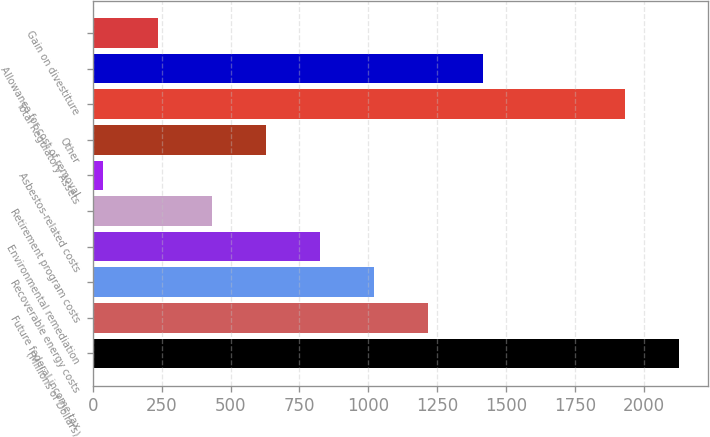<chart> <loc_0><loc_0><loc_500><loc_500><bar_chart><fcel>(Millions of Dollars)<fcel>Future federal income tax<fcel>Recoverable energy costs<fcel>Environmental remediation<fcel>Retirement program costs<fcel>Asbestos-related costs<fcel>Other<fcel>Total Regulatory Assets<fcel>Allowance for cost of removal<fcel>Gain on divestiture<nl><fcel>2125.8<fcel>1217.4<fcel>1021<fcel>824.6<fcel>431.8<fcel>39<fcel>628.2<fcel>1929.4<fcel>1413.8<fcel>235.4<nl></chart> 